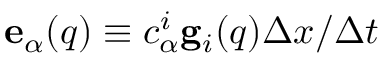<formula> <loc_0><loc_0><loc_500><loc_500>{ e } _ { \alpha } ( { q } ) \equiv c _ { \alpha } ^ { i } { g } _ { i } ( { q } ) \Delta x / \Delta t</formula> 